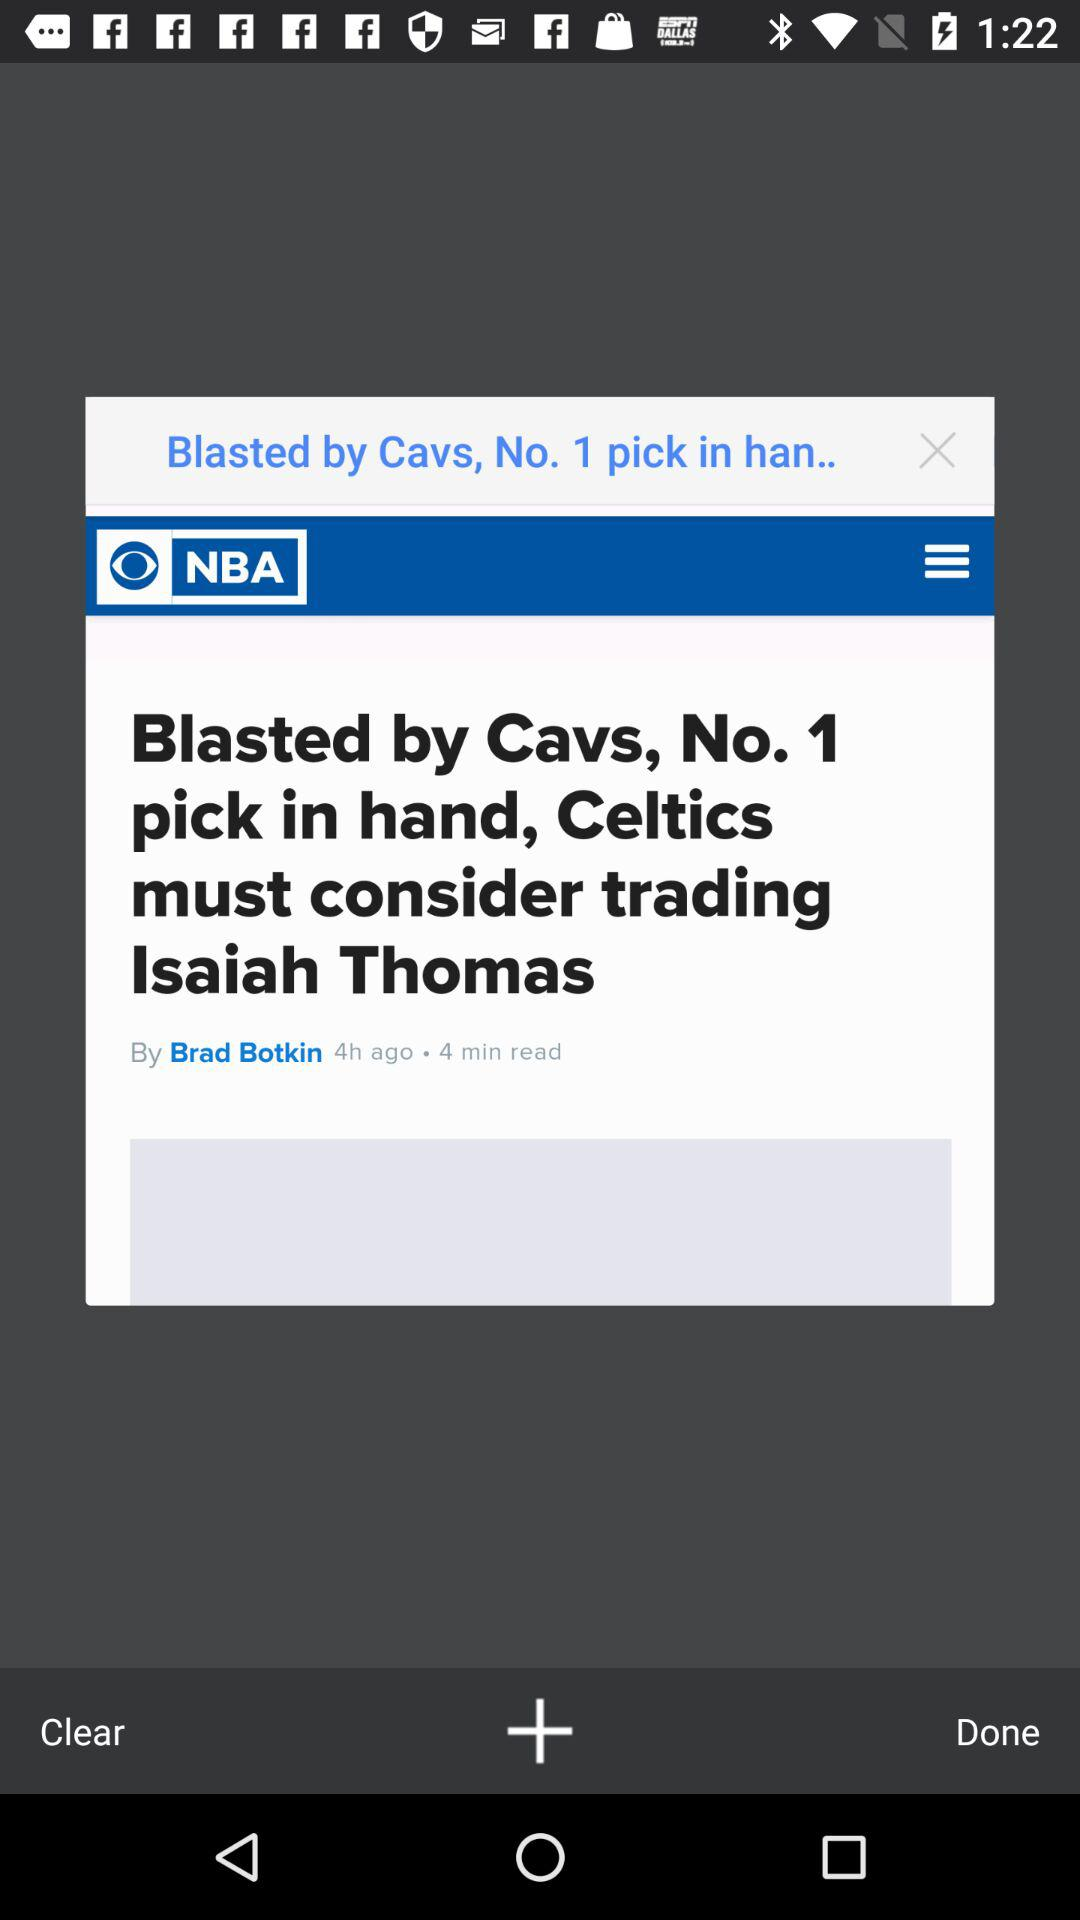Which team will the "Celtics" play next?
When the provided information is insufficient, respond with <no answer>. <no answer> 